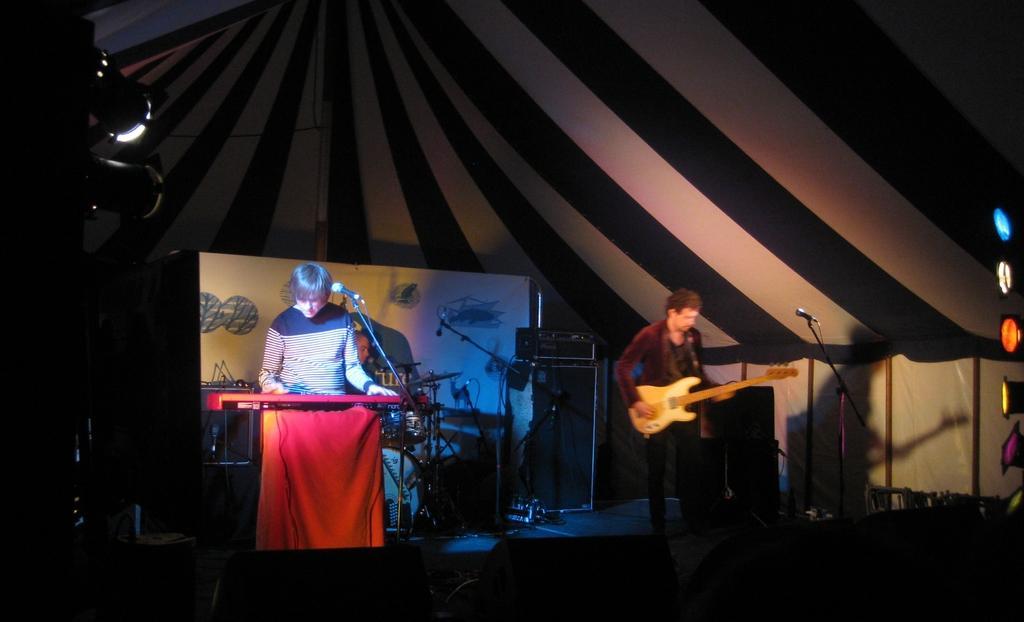Describe this image in one or two sentences. In this picture there is a man who is standing and playing a piano. There is another man standing and playing a guitar. There is light at the background. There is a chair. 